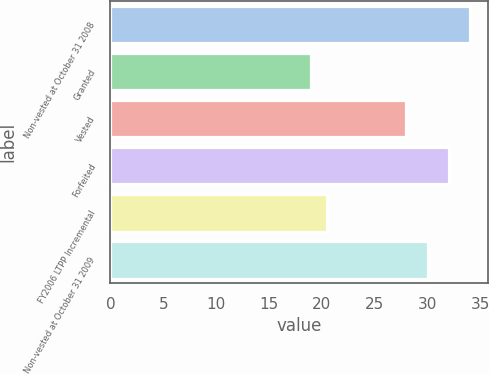<chart> <loc_0><loc_0><loc_500><loc_500><bar_chart><fcel>Non-vested at October 31 2008<fcel>Granted<fcel>Vested<fcel>Forfeited<fcel>FY2006 LTPP Incremental<fcel>Non-vested at October 31 2009<nl><fcel>34<fcel>19<fcel>28<fcel>32<fcel>20.5<fcel>30<nl></chart> 